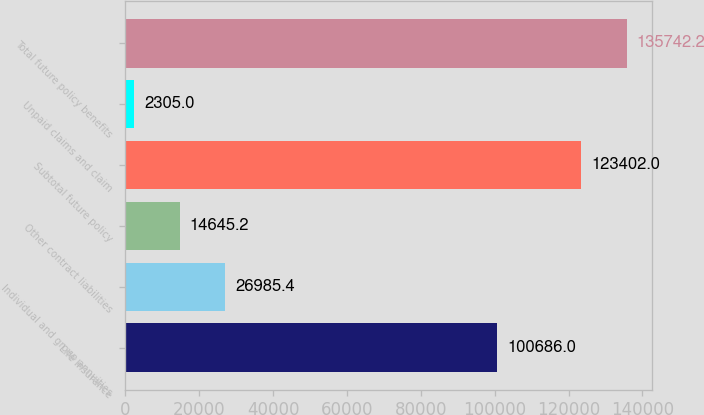<chart> <loc_0><loc_0><loc_500><loc_500><bar_chart><fcel>Life Insurance<fcel>Individual and group annuities<fcel>Other contract liabilities<fcel>Subtotal future policy<fcel>Unpaid claims and claim<fcel>Total future policy benefits<nl><fcel>100686<fcel>26985.4<fcel>14645.2<fcel>123402<fcel>2305<fcel>135742<nl></chart> 